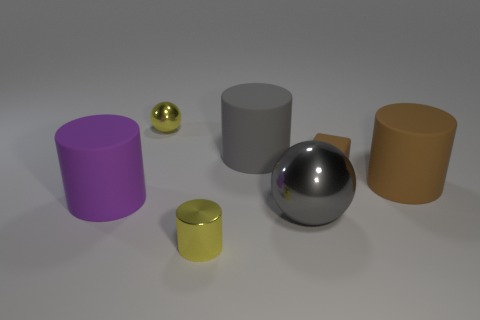Add 1 big brown rubber objects. How many objects exist? 8 Subtract all blocks. How many objects are left? 6 Add 2 large metallic objects. How many large metallic objects are left? 3 Add 7 matte blocks. How many matte blocks exist? 8 Subtract 1 brown blocks. How many objects are left? 6 Subtract all spheres. Subtract all big metallic spheres. How many objects are left? 4 